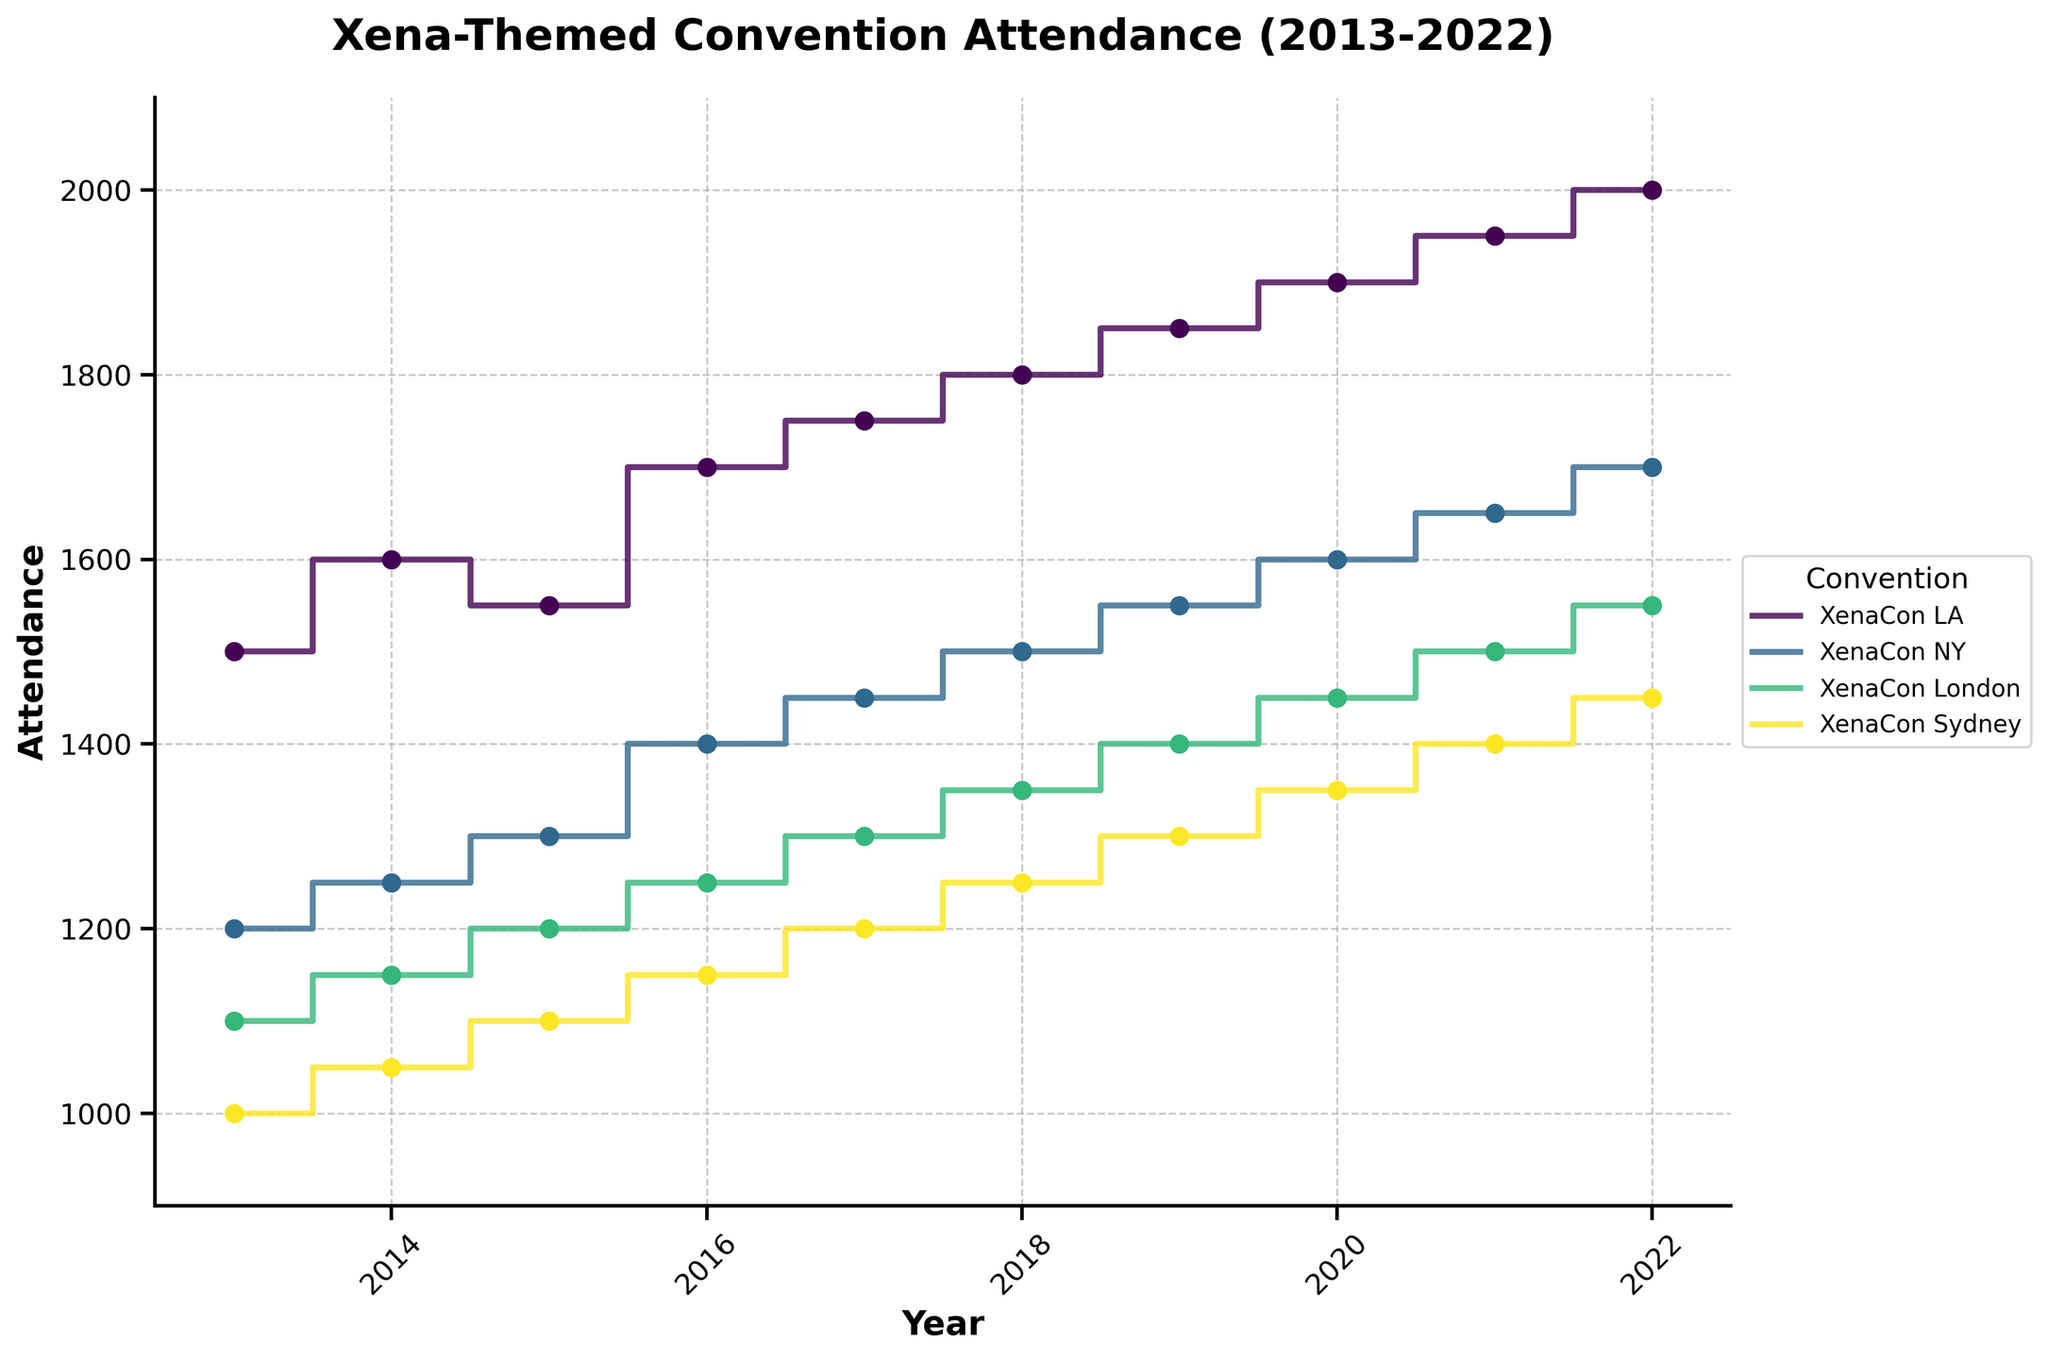What is the title of the figure? The title is located at the top of the figure and gives a summary of the information being visualized.
Answer: Xena-Themed Convention Attendance (2013-2022) What is plotted on the x-axis? The x-axis represents the time period over which the data is collected and is labeled accordingly.
Answer: Year What is plotted on the y-axis? The y-axis represents the number of attendees at each convention and is accordingly labeled.
Answer: Attendance Which convention had the highest attendance in 2022? By locating the year 2022 on the x-axis and finding the highest point on the y-axis for this year, we can identify the convention with the maximum attendance.
Answer: XenaCon LA Between which years did XenaCon Sydney see the largest attendance growth? By comparing the attendance changes year over year using the steps in the plot for XenaCon Sydney, the period with the largest increase can be identified.
Answer: 2019 to 2020 In what year did XenaCon London have an attendance of 1250? Locate the step corresponding to an attendance of 1250 on the y-axis, then trace horizontally to find the corresponding year.
Answer: 2016 How does the attendance trend of XenaCon LA from 2013 to 2022 compare to XenaCon NY? Compare the step plot lines of both conventions over the years and determine whether one has a steeper increase, remains stable, or decreases.
Answer: XenaCon LA shows a generally steeper increasing trend compared to XenaCon NY What was the total attendance at XenaCon LA over the past decade? By summing up the attendance figures for each year from 2013 to 2022 for XenaCon LA, the total attendance can be calculated.
Answer: 16800 Which convention had the smallest attendance in 2015? Find the step corresponding to the year 2015 on the x-axis, then see which convention reached the lowest value on the y-axis.
Answer: XenaCon Sydney Between XenaCon NY and XenaCon London, which saw a higher increase in attendance from 2014 to 2018? Calculate the difference in attendance between 2014 and 2018 for both conventions and compare them.
Answer: XenaCon NY In which year did all conventions see an increase in attendance compared to the previous year? Identify a point in the step plots where all conventions show an upward movement compared to the year before.
Answer: 2016 